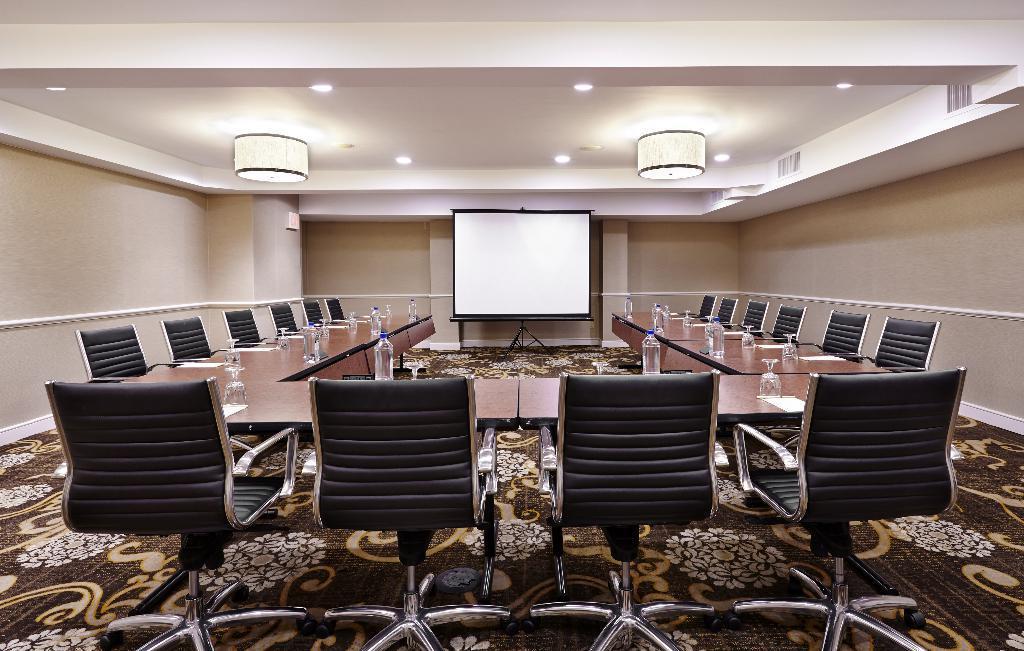Please provide a concise description of this image. In this image it looks like it is a seminar hall in which there are tables in the middle and there are chairs around it. In the middle there is a screen. At the top there is ceiling with the lights. On the table there are glasses,bottles and papers. 